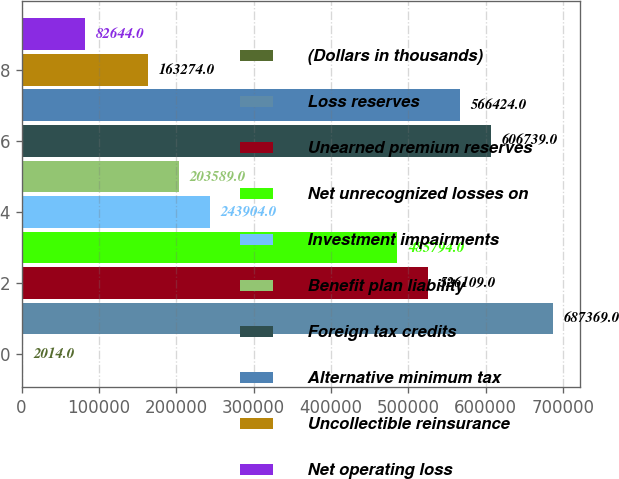Convert chart. <chart><loc_0><loc_0><loc_500><loc_500><bar_chart><fcel>(Dollars in thousands)<fcel>Loss reserves<fcel>Unearned premium reserves<fcel>Net unrecognized losses on<fcel>Investment impairments<fcel>Benefit plan liability<fcel>Foreign tax credits<fcel>Alternative minimum tax<fcel>Uncollectible reinsurance<fcel>Net operating loss<nl><fcel>2014<fcel>687369<fcel>526109<fcel>485794<fcel>243904<fcel>203589<fcel>606739<fcel>566424<fcel>163274<fcel>82644<nl></chart> 